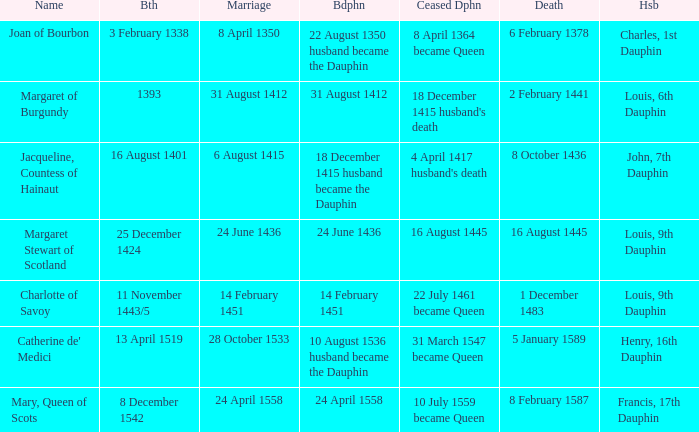When was the death of the person with husband charles, 1st dauphin? 6 February 1378. 